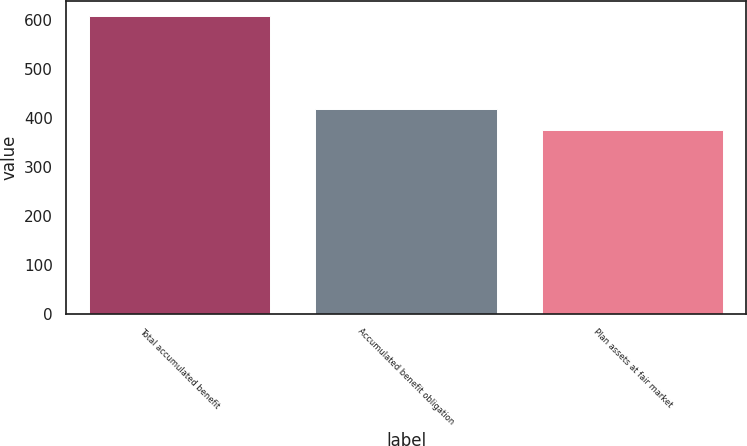Convert chart. <chart><loc_0><loc_0><loc_500><loc_500><bar_chart><fcel>Total accumulated benefit<fcel>Accumulated benefit obligation<fcel>Plan assets at fair market<nl><fcel>609.1<fcel>417.4<fcel>375.5<nl></chart> 